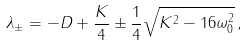<formula> <loc_0><loc_0><loc_500><loc_500>\lambda _ { \pm } = - D + \frac { K } { 4 } \pm \frac { 1 } { 4 } \sqrt { K ^ { 2 } - 1 6 \omega _ { 0 } ^ { 2 } } \, ,</formula> 